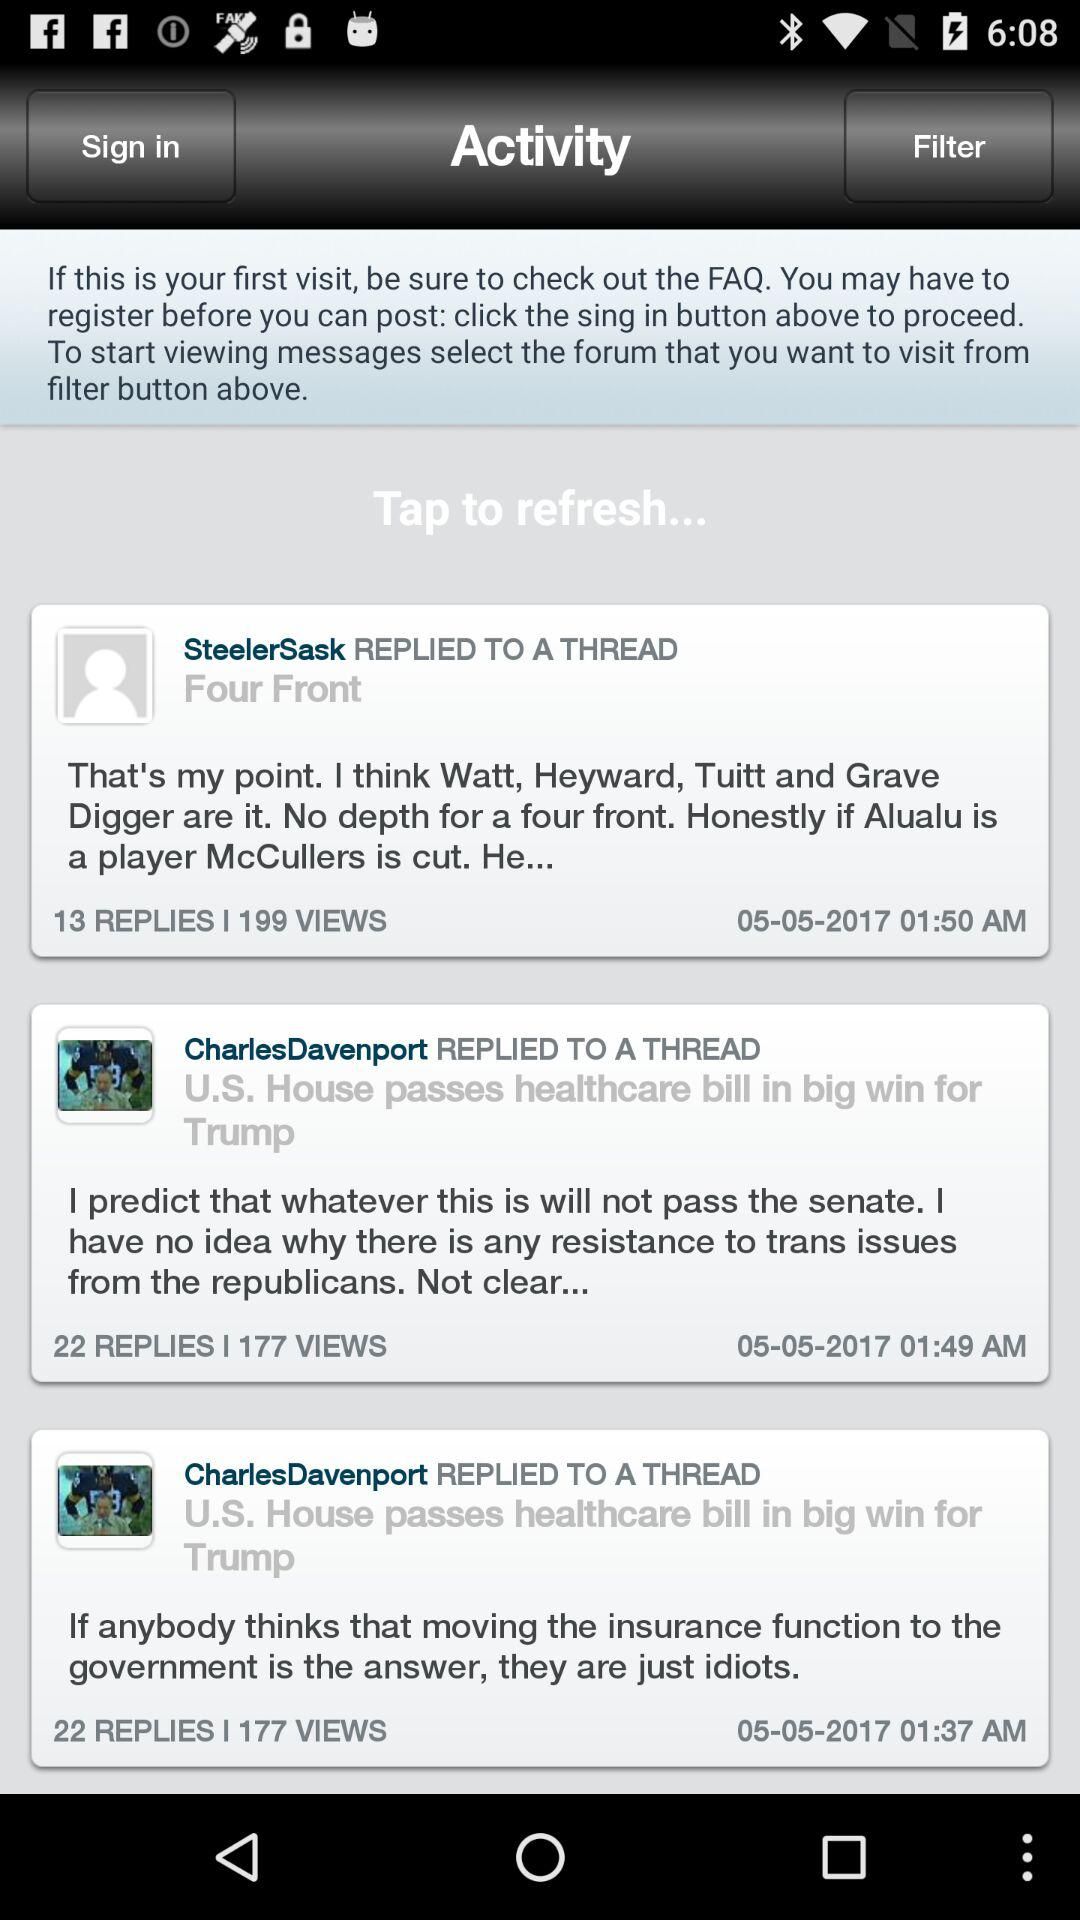How many replies did CharlesDavenport's thread get, which was posted at 01:49 AM? CharlesDavenport's thread got 22 replies. 